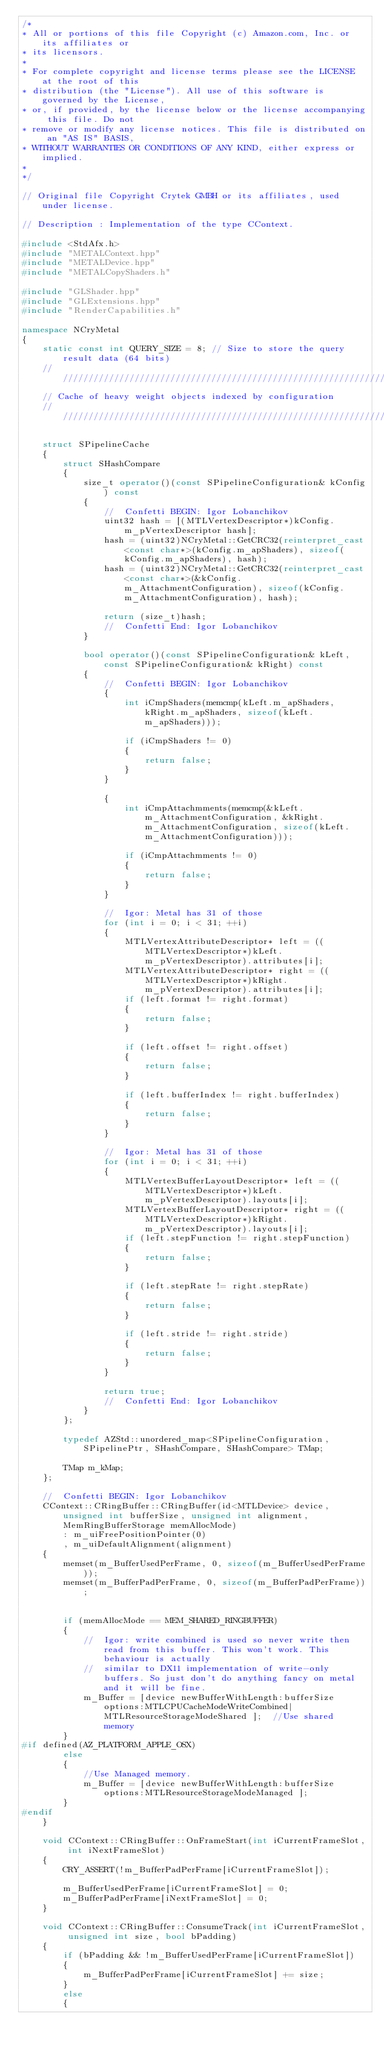<code> <loc_0><loc_0><loc_500><loc_500><_C++_>/*
* All or portions of this file Copyright (c) Amazon.com, Inc. or its affiliates or
* its licensors.
*
* For complete copyright and license terms please see the LICENSE at the root of this
* distribution (the "License"). All use of this software is governed by the License,
* or, if provided, by the license below or the license accompanying this file. Do not
* remove or modify any license notices. This file is distributed on an "AS IS" BASIS,
* WITHOUT WARRANTIES OR CONDITIONS OF ANY KIND, either express or implied.
*
*/

// Original file Copyright Crytek GMBH or its affiliates, used under license.

// Description : Implementation of the type CContext.

#include <StdAfx.h>
#include "METALContext.hpp"
#include "METALDevice.hpp"
#include "METALCopyShaders.h"

#include "GLShader.hpp"
#include "GLExtensions.hpp"
#include "RenderCapabilities.h"

namespace NCryMetal
{
    static const int QUERY_SIZE = 8; // Size to store the query result data (64 bits)
    ////////////////////////////////////////////////////////////////////////////
    // Cache of heavy weight objects indexed by configuration
    ////////////////////////////////////////////////////////////////////////////

    struct SPipelineCache
    {
        struct SHashCompare
        {
            size_t operator()(const SPipelineConfiguration& kConfig) const
            {
                //  Confetti BEGIN: Igor Lobanchikov
                uint32 hash = [(MTLVertexDescriptor*)kConfig.m_pVertexDescriptor hash];
                hash = (uint32)NCryMetal::GetCRC32(reinterpret_cast<const char*>(kConfig.m_apShaders), sizeof(kConfig.m_apShaders), hash);
                hash = (uint32)NCryMetal::GetCRC32(reinterpret_cast<const char*>(&kConfig.m_AttachmentConfiguration), sizeof(kConfig.m_AttachmentConfiguration), hash);

                return (size_t)hash;
                //  Confetti End: Igor Lobanchikov
            }

            bool operator()(const SPipelineConfiguration& kLeft, const SPipelineConfiguration& kRight) const
            {
                //  Confetti BEGIN: Igor Lobanchikov
                {
                    int iCmpShaders(memcmp(kLeft.m_apShaders, kRight.m_apShaders, sizeof(kLeft.m_apShaders)));

                    if (iCmpShaders != 0)
                    {
                        return false;
                    }
                }

                {
                    int iCmpAttachmments(memcmp(&kLeft.m_AttachmentConfiguration, &kRight.m_AttachmentConfiguration, sizeof(kLeft.m_AttachmentConfiguration)));

                    if (iCmpAttachmments != 0)
                    {
                        return false;
                    }
                }

                //  Igor: Metal has 31 of those
                for (int i = 0; i < 31; ++i)
                {
                    MTLVertexAttributeDescriptor* left = ((MTLVertexDescriptor*)kLeft.m_pVertexDescriptor).attributes[i];
                    MTLVertexAttributeDescriptor* right = ((MTLVertexDescriptor*)kRight.m_pVertexDescriptor).attributes[i];
                    if (left.format != right.format)
                    {
                        return false;
                    }

                    if (left.offset != right.offset)
                    {
                        return false;
                    }

                    if (left.bufferIndex != right.bufferIndex)
                    {
                        return false;
                    }
                }

                //  Igor: Metal has 31 of those
                for (int i = 0; i < 31; ++i)
                {
                    MTLVertexBufferLayoutDescriptor* left = ((MTLVertexDescriptor*)kLeft.m_pVertexDescriptor).layouts[i];
                    MTLVertexBufferLayoutDescriptor* right = ((MTLVertexDescriptor*)kRight.m_pVertexDescriptor).layouts[i];
                    if (left.stepFunction != right.stepFunction)
                    {
                        return false;
                    }

                    if (left.stepRate != right.stepRate)
                    {
                        return false;
                    }

                    if (left.stride != right.stride)
                    {
                        return false;
                    }
                }

                return true;
                //  Confetti End: Igor Lobanchikov
            }
        };

        typedef AZStd::unordered_map<SPipelineConfiguration, SPipelinePtr, SHashCompare, SHashCompare> TMap;

        TMap m_kMap;
    };

    //  Confetti BEGIN: Igor Lobanchikov
    CContext::CRingBuffer::CRingBuffer(id<MTLDevice> device, unsigned int bufferSize, unsigned int alignment, MemRingBufferStorage memAllocMode)
        : m_uiFreePositionPointer(0)
        , m_uiDefaultAlignment(alignment)
    {
        memset(m_BufferUsedPerFrame, 0, sizeof(m_BufferUsedPerFrame));
        memset(m_BufferPadPerFrame, 0, sizeof(m_BufferPadPerFrame));

        
        if (memAllocMode == MEM_SHARED_RINGBUFFER)
        {
            //  Igor: write combined is used so never write then read from this buffer. This won't work. This behaviour is actually
            //  similar to DX11 implementation of write-only buffers. So just don't do anything fancy on metal and it will be fine.
            m_Buffer = [device newBufferWithLength:bufferSize options:MTLCPUCacheModeWriteCombined|MTLResourceStorageModeShared ];  //Use shared memory
        }
#if defined(AZ_PLATFORM_APPLE_OSX)
        else
        {
            //Use Managed memory.
            m_Buffer = [device newBufferWithLength:bufferSize options:MTLResourceStorageModeManaged ];
        }
#endif
    }

    void CContext::CRingBuffer::OnFrameStart(int iCurrentFrameSlot, int iNextFrameSlot)
    {
        CRY_ASSERT(!m_BufferPadPerFrame[iCurrentFrameSlot]);

        m_BufferUsedPerFrame[iCurrentFrameSlot] = 0;
        m_BufferPadPerFrame[iNextFrameSlot] = 0;
    }

    void CContext::CRingBuffer::ConsumeTrack(int iCurrentFrameSlot, unsigned int size, bool bPadding)
    {
        if (bPadding && !m_BufferUsedPerFrame[iCurrentFrameSlot])
        {
            m_BufferPadPerFrame[iCurrentFrameSlot] += size;
        }
        else
        {</code> 